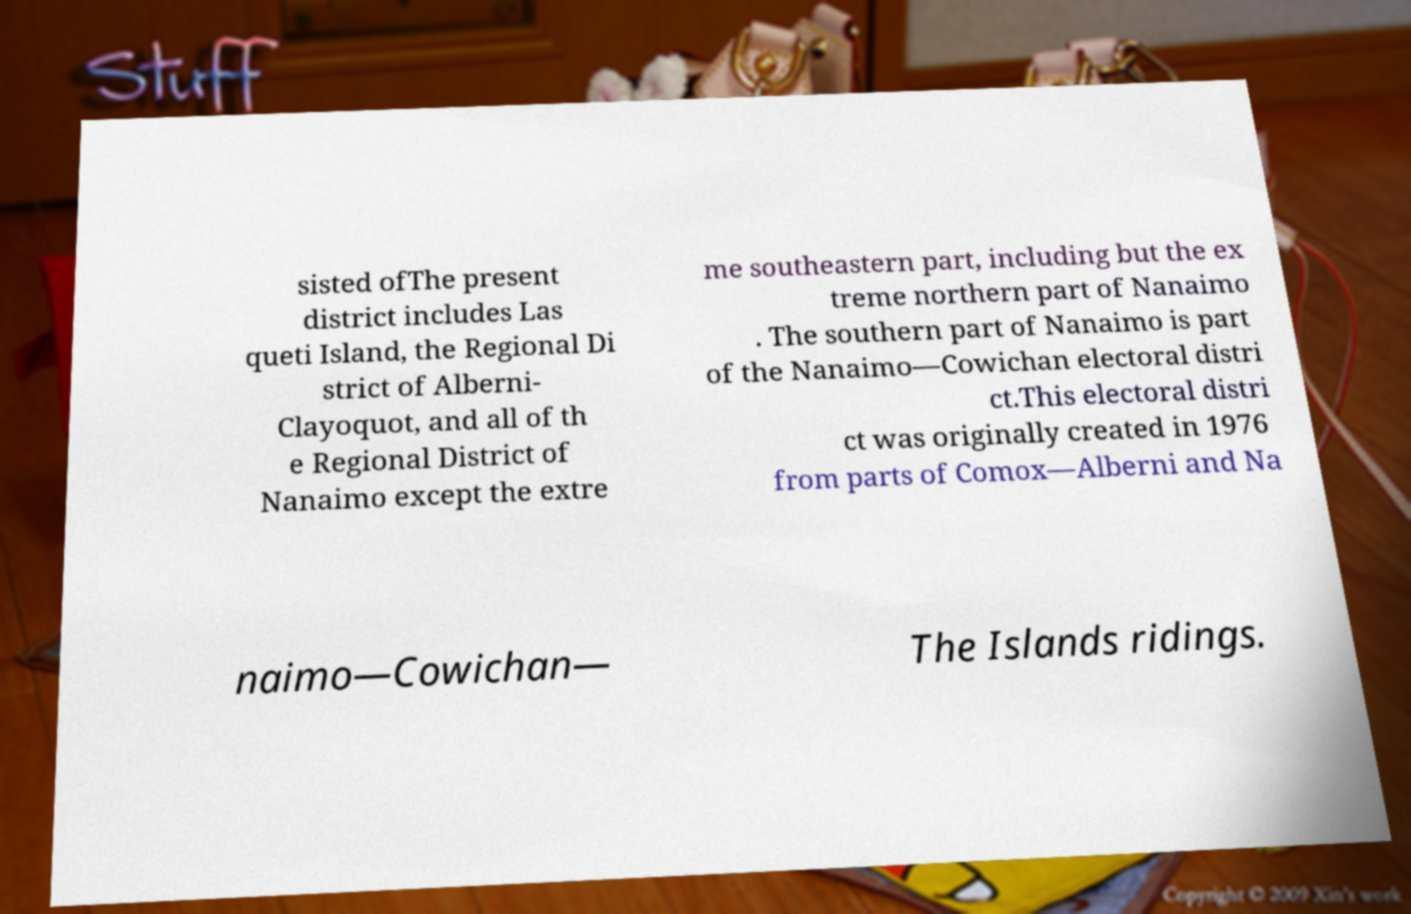Please identify and transcribe the text found in this image. sisted ofThe present district includes Las queti Island, the Regional Di strict of Alberni- Clayoquot, and all of th e Regional District of Nanaimo except the extre me southeastern part, including but the ex treme northern part of Nanaimo . The southern part of Nanaimo is part of the Nanaimo—Cowichan electoral distri ct.This electoral distri ct was originally created in 1976 from parts of Comox—Alberni and Na naimo—Cowichan— The Islands ridings. 